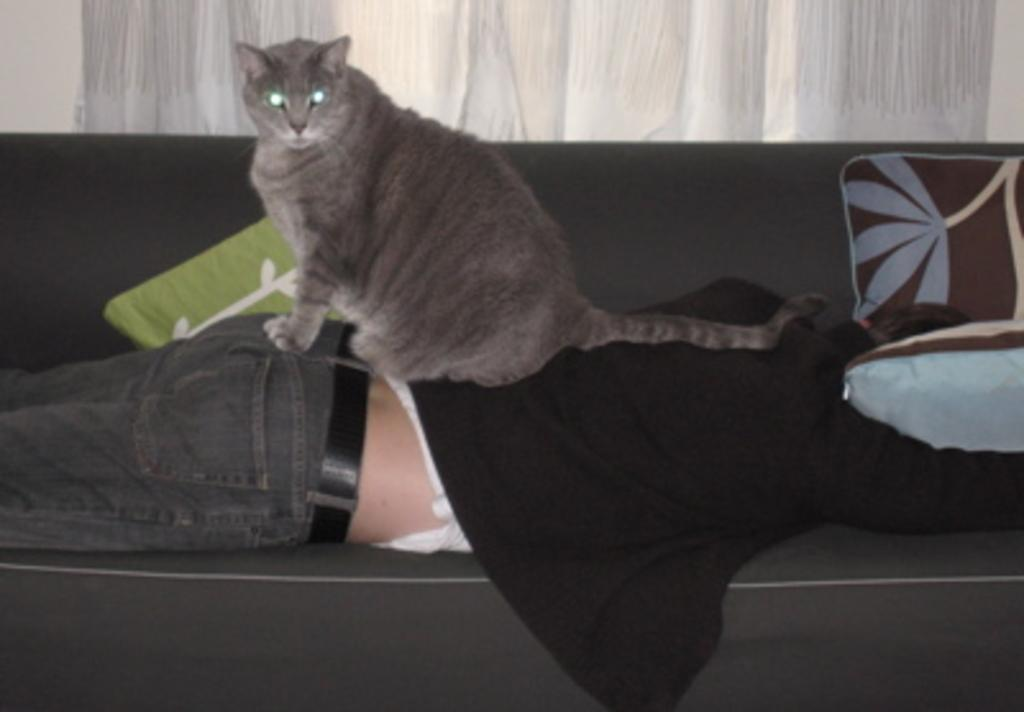What is the main subject of the image? The main subject of the image is a man. What is the man doing in the image? The man is lying on a sofa in the image. What is the man wearing in the image? The man is wearing a black color shirt and denim pants in the image. Is there any animal present in the image? Yes, there is a cat sitting on the man in the image. What can be seen in the background of the image? There is a window with a white color curtain in the background of the image. What type of pollution can be seen in the image? There is no pollution visible in the image. Can you tell me how many hills are present in the image? There are no hills present in the image. 